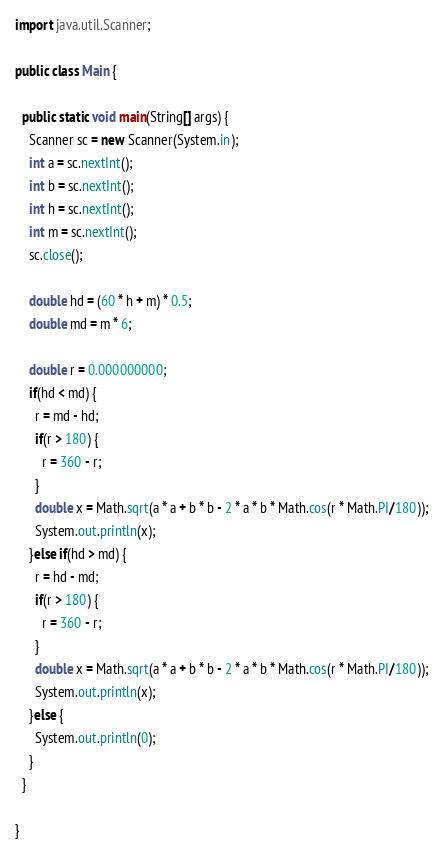<code> <loc_0><loc_0><loc_500><loc_500><_Java_>
import java.util.Scanner;

public class Main {

  public static void main(String[] args) {
    Scanner sc = new Scanner(System.in);
    int a = sc.nextInt();
    int b = sc.nextInt();
    int h = sc.nextInt();
    int m = sc.nextInt();
    sc.close();

    double hd = (60 * h + m) * 0.5;
    double md = m * 6;

    double r = 0.000000000;
    if(hd < md) {
      r = md - hd;
      if(r > 180) {
        r = 360 - r;
      }
      double x = Math.sqrt(a * a + b * b - 2 * a * b * Math.cos(r * Math.PI/180));
      System.out.println(x);
    }else if(hd > md) {
      r = hd - md;
      if(r > 180) {
        r = 360 - r;
      }
      double x = Math.sqrt(a * a + b * b - 2 * a * b * Math.cos(r * Math.PI/180));
      System.out.println(x);
    }else {
      System.out.println(0);
    }
  }

}
</code> 